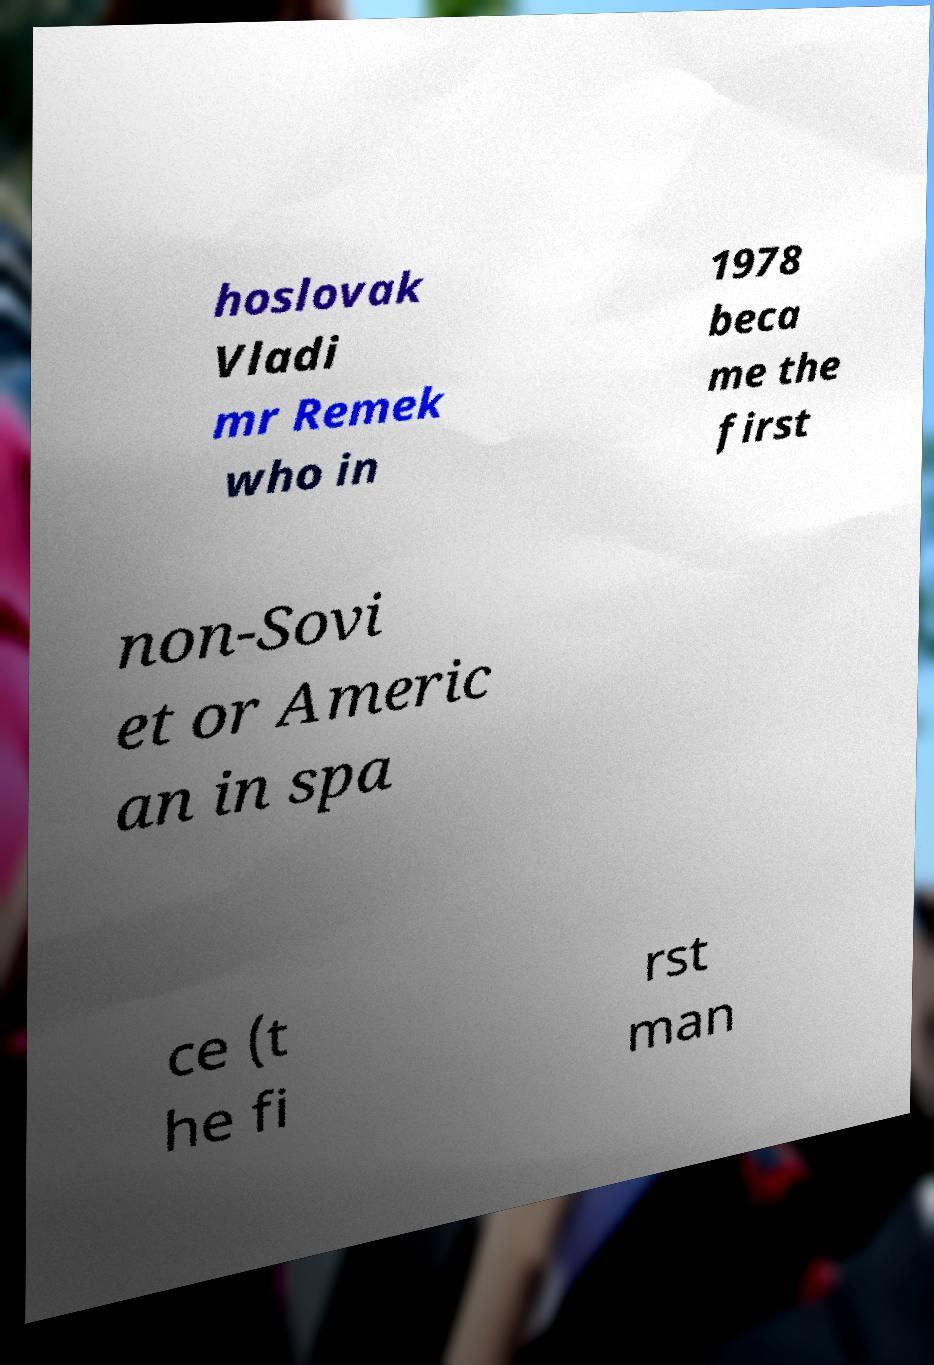Could you assist in decoding the text presented in this image and type it out clearly? hoslovak Vladi mr Remek who in 1978 beca me the first non-Sovi et or Americ an in spa ce (t he fi rst man 